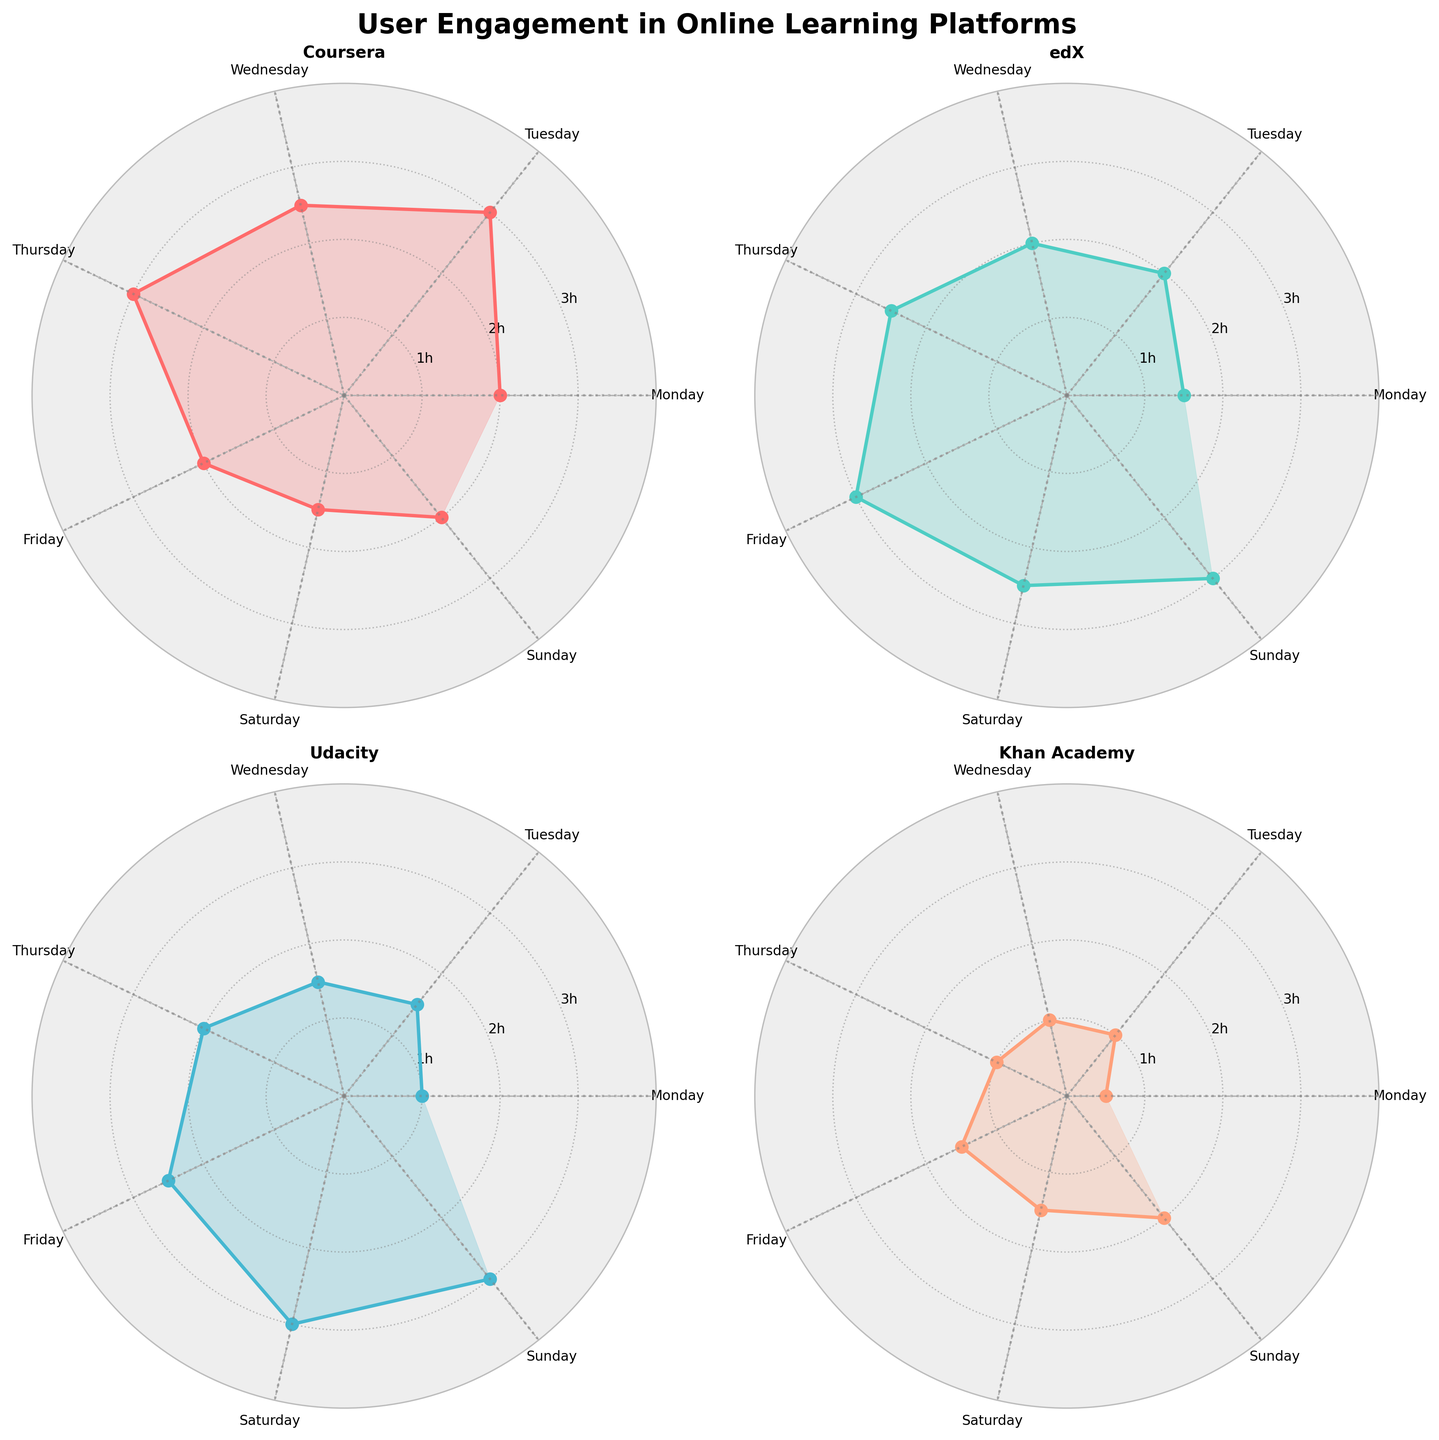What is the title of the figure? The title is typically located at the top of the figure. In this case, it reads "User Engagement in Online Learning Platforms", as stated in the code at the line where `fig.suptitle` is defined.
Answer: User Engagement in Online Learning Platforms Which platform has the highest engagement on Sunday? To determine this, look at the radii values on Sunday for each subplot. The platform with the highest value (radii) for Sunday will have the highest engagement. In this case, both edX and Udacity have the highest engagement at 3 hours.
Answer: edX and Udacity How many platforms are compared in the figure? The number of platforms is determined by the unique values in the 'platforms' array which results in four distinct platforms. Thus, the figure contains four subplots comparing these platforms.
Answer: 4 Which day has the lowest engagement for Khan Academy? Look at the plot for Khan Academy and find the smallest radii value. The smallest engagement value for Khan Academy is on Monday, at 0.5 hours.
Answer: Monday What is the average time spent on Coursera for the whole week? Sum all the radii values for Coursera and then divide by the number of days (7). Calculations: (2 + 3 + 2.5 + 3 + 2 + 1.5 + 2) / 7 = 2.2857.
Answer: 2.29 hours (approximately) Which platform has a consistent increase in engagement from Monday to Sunday? Inspect each subplot to see the trend of engagement over the week. Udacity shows a consistent increase from Monday to Sunday, starting at 1 hour on Monday and reaching up to 3 hours on Sunday.
Answer: Udacity Which two days have the same engagement time for edX? Inspect the plot for edX, looking for days with the same radii values. edX has the same engagement time (2 hours) on Tuesday and Wednesday.
Answer: Tuesday and Wednesday Between Coursera and Khan Academy, which platform has a higher engagement on Friday? Compare the radii values for both platforms on Friday. Coursera has 2 hours, while Khan Academy has 1.5 hours. Coursera has the higher engagement.
Answer: Coursera On which day does edX have the peak engagement? Look at the plot for edX and find the highest radii value. The peak engagement for edX is on Sunday with 3 hours.
Answer: Sunday 